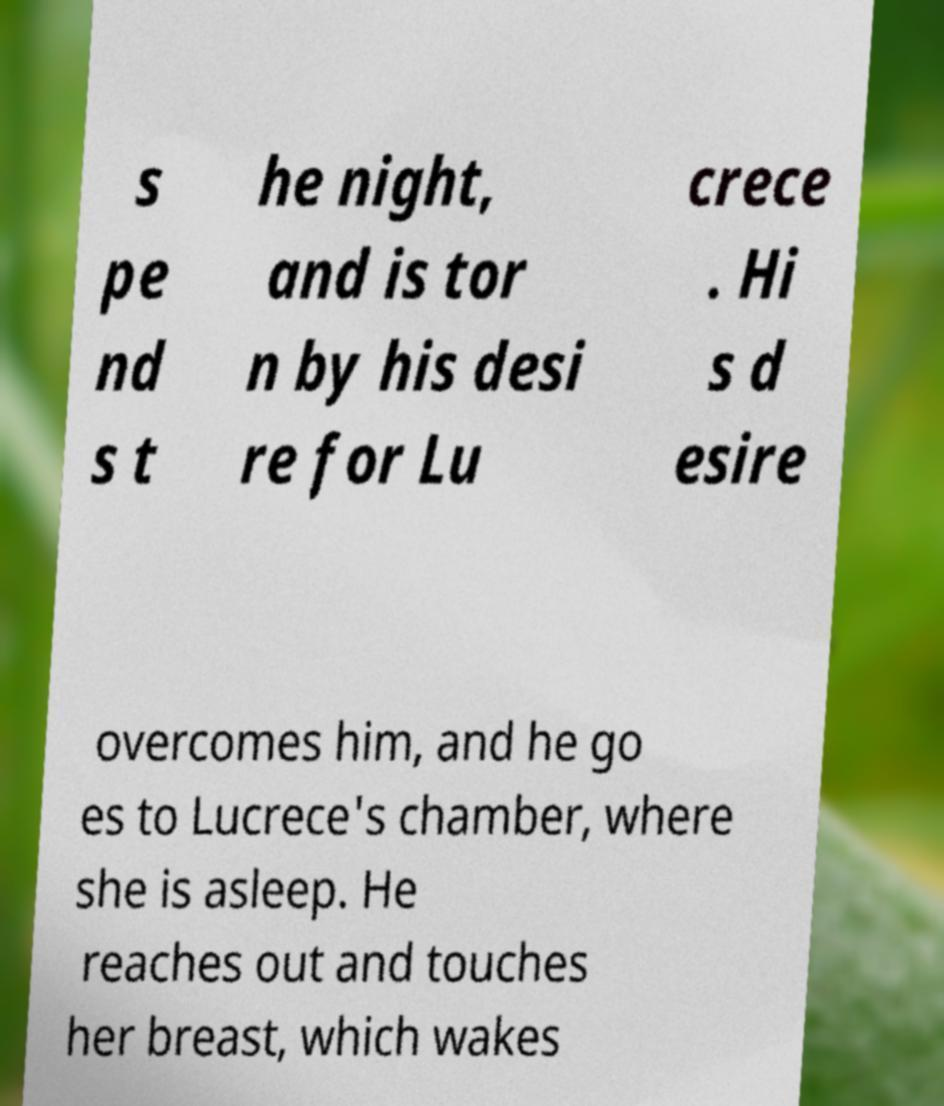What messages or text are displayed in this image? I need them in a readable, typed format. s pe nd s t he night, and is tor n by his desi re for Lu crece . Hi s d esire overcomes him, and he go es to Lucrece's chamber, where she is asleep. He reaches out and touches her breast, which wakes 